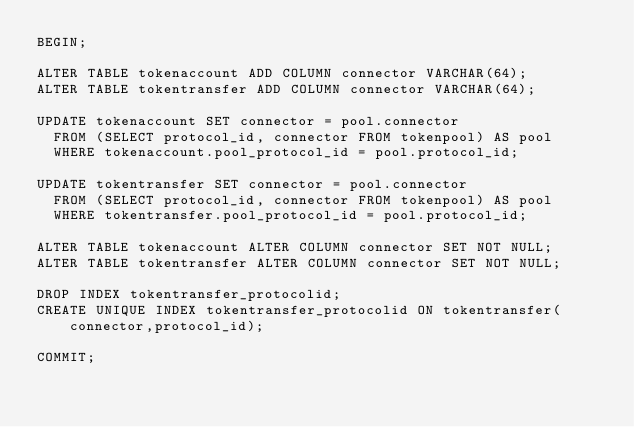<code> <loc_0><loc_0><loc_500><loc_500><_SQL_>BEGIN;

ALTER TABLE tokenaccount ADD COLUMN connector VARCHAR(64);
ALTER TABLE tokentransfer ADD COLUMN connector VARCHAR(64);

UPDATE tokenaccount SET connector = pool.connector
  FROM (SELECT protocol_id, connector FROM tokenpool) AS pool
  WHERE tokenaccount.pool_protocol_id = pool.protocol_id;

UPDATE tokentransfer SET connector = pool.connector
  FROM (SELECT protocol_id, connector FROM tokenpool) AS pool
  WHERE tokentransfer.pool_protocol_id = pool.protocol_id;

ALTER TABLE tokenaccount ALTER COLUMN connector SET NOT NULL;
ALTER TABLE tokentransfer ALTER COLUMN connector SET NOT NULL;

DROP INDEX tokentransfer_protocolid;
CREATE UNIQUE INDEX tokentransfer_protocolid ON tokentransfer(connector,protocol_id);

COMMIT;
</code> 